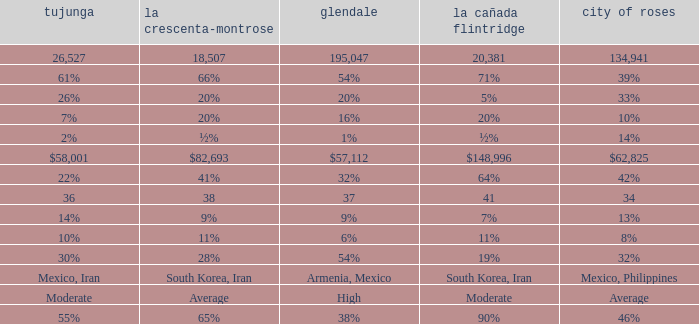When Pasadena is at 10%, what is La Crescenta-Montrose? 20%. 